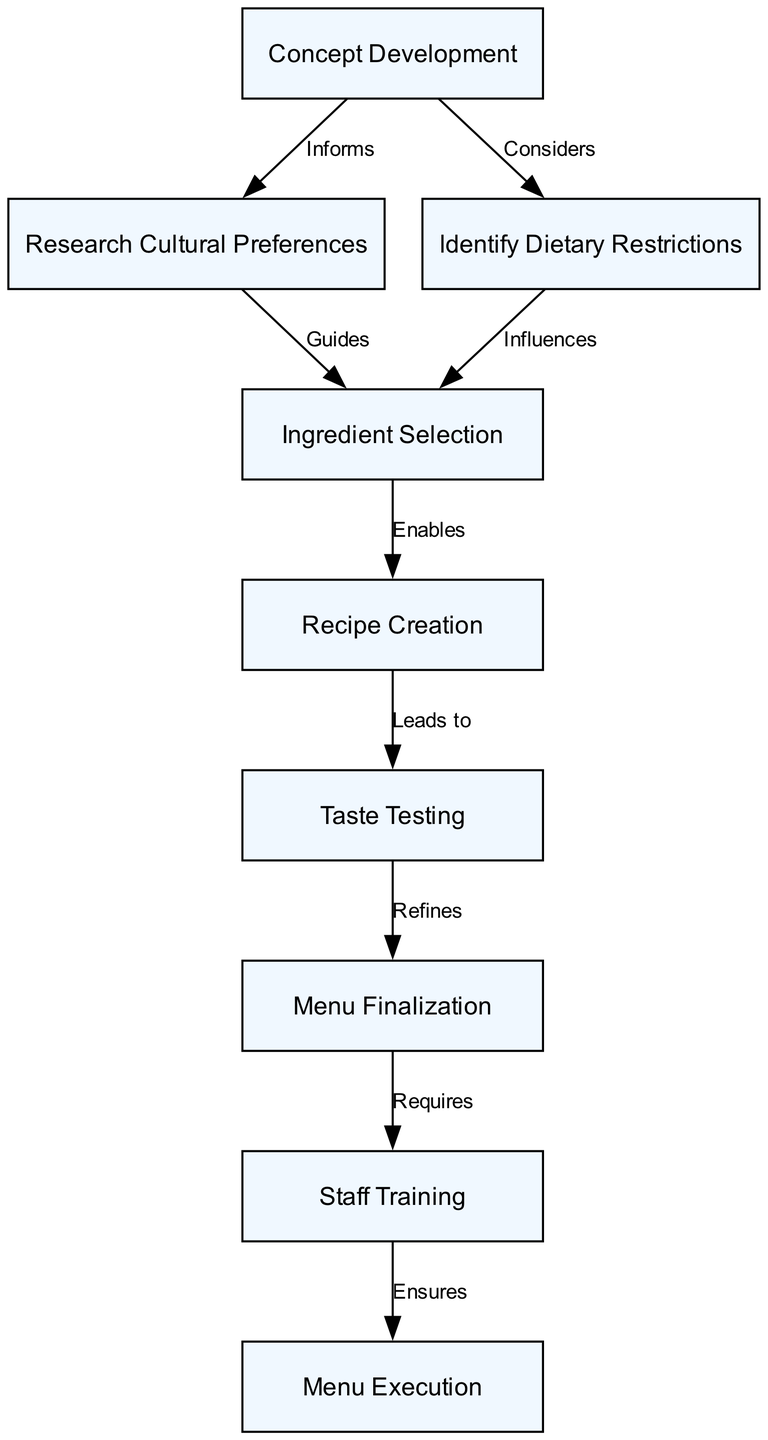What is the first step in the menu planning process? The first step is "Concept Development," as indicated in the diagram as the starting node.
Answer: Concept Development How many nodes are present in the diagram? There are nine nodes present, which represent different steps in the menu planning process.
Answer: Nine What label is associated with the edge connecting "Concept Development" and "Research Cultural Preferences"? The edge connecting these two nodes is labeled "Informs," indicating the relationship.
Answer: Informs What role does "Taste Testing" play in the menu planning process? "Taste Testing" is indicated as a step that "Refines" the menu before finalization, showing its importance in ensuring quality.
Answer: Refines Which node does "Ingredient Selection" influence? "Ingredient Selection" influences "Recipe Creation," as indicated in the diagram by the edge labeled "Enables."
Answer: Recipe Creation What is the final step of the menu planning process? The final step is "Menu Execution," which is the last node in the flowchart indicating the completion of the process.
Answer: Menu Execution What does the edge from "Research Cultural Preferences" to "Ingredient Selection" indicate? The edge labeled "Guides" shows that the research on cultural preferences directs the choice of ingredients.
Answer: Guides Which node is connected to "Menu Finalization" and what is the relationship? "Menu Finalization" is connected to "Staff Training," and the relationship is indicated by the edge labeled "Requires."
Answer: Staff Training Which step directly follows "Recipe Creation"? "Taste Testing" directly follows "Recipe Creation," as shown by the edge labeled "Leads to."
Answer: Taste Testing 